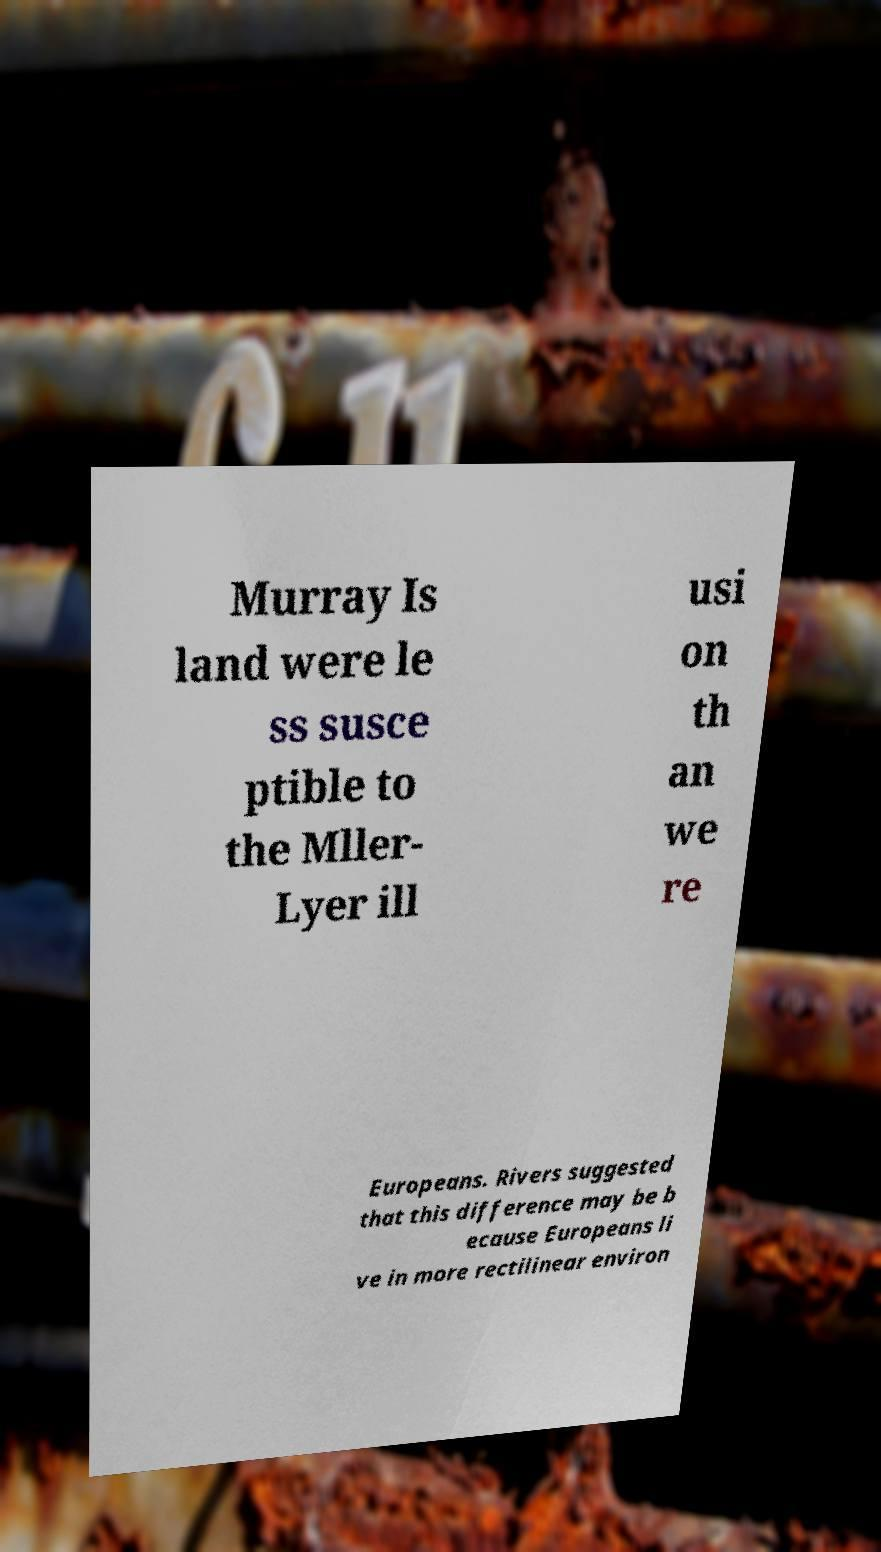There's text embedded in this image that I need extracted. Can you transcribe it verbatim? Murray Is land were le ss susce ptible to the Mller- Lyer ill usi on th an we re Europeans. Rivers suggested that this difference may be b ecause Europeans li ve in more rectilinear environ 